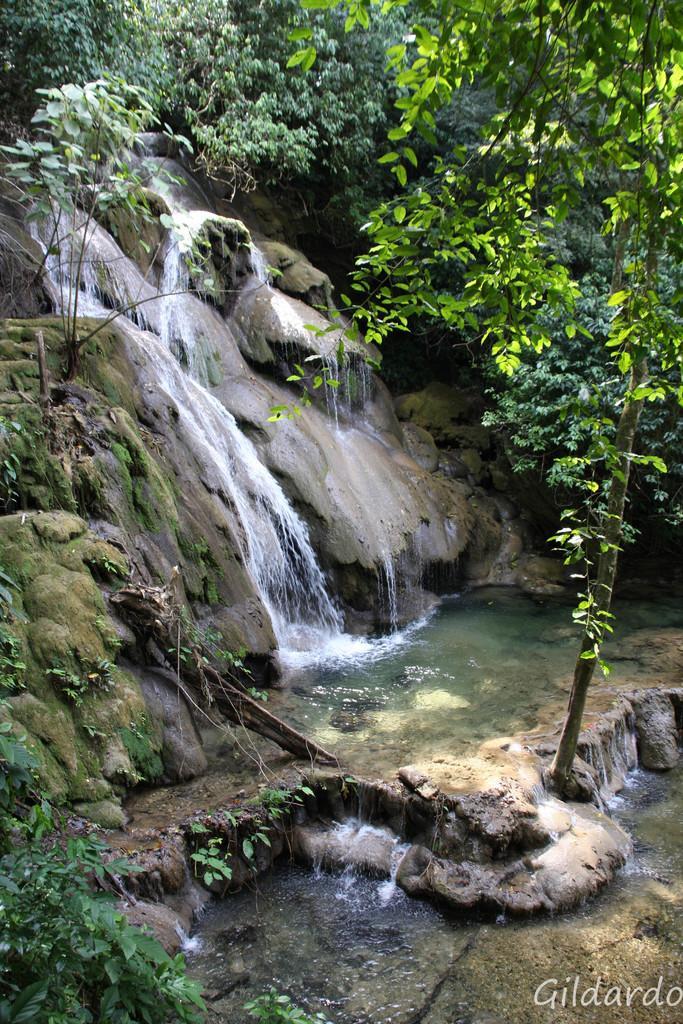Could you give a brief overview of what you see in this image? In this image in the center there is a waterfall and some rocks and plants, in the background there are a group of trees. 